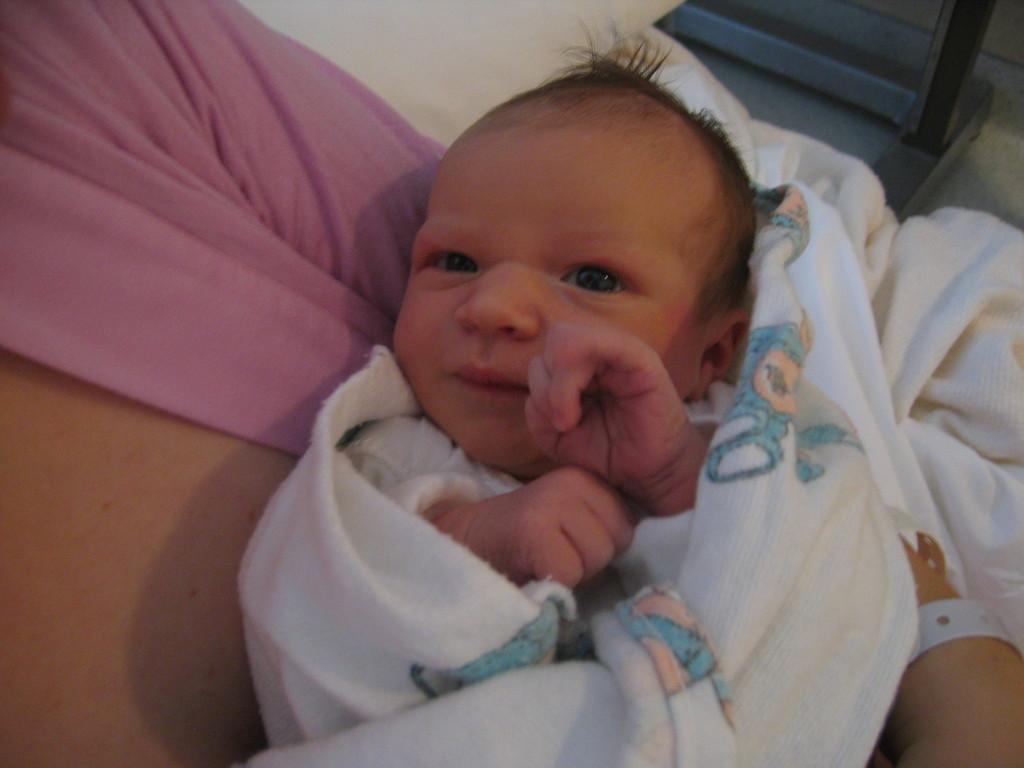What is the main subject of the image? The main subject of the image is a woman. What is the woman doing in the image? The woman is carrying a baby. How is the baby being held or carried by the woman? The baby is wrapped in a cloth. What is visible in the background of the image? There is a wall visible in the image. What type of egg can be seen on the woman's head in the image? There is no egg present on the woman's head in the image. How does the baby move around while being carried by the woman? The baby does not move around while being carried by the woman; it is wrapped in a cloth and being held by the woman. 